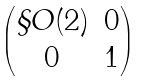<formula> <loc_0><loc_0><loc_500><loc_500>\begin{pmatrix} \S O ( 2 ) & 0 \\ 0 & 1 \end{pmatrix}</formula> 